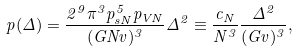<formula> <loc_0><loc_0><loc_500><loc_500>p ( \Delta ) = \frac { 2 ^ { 9 } \pi ^ { 3 } p _ { s N } ^ { 5 } p _ { V N } } { ( G N v ) ^ { 3 } } \Delta ^ { 2 } \equiv \frac { c _ { N } } { N ^ { 3 } } \frac { \Delta ^ { 2 } } { ( G v ) ^ { 3 } } ,</formula> 